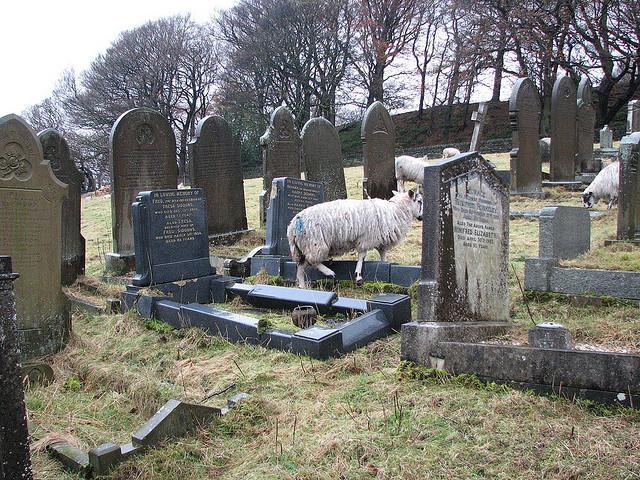How many cats are on the second shelf from the top?
Give a very brief answer. 0. 